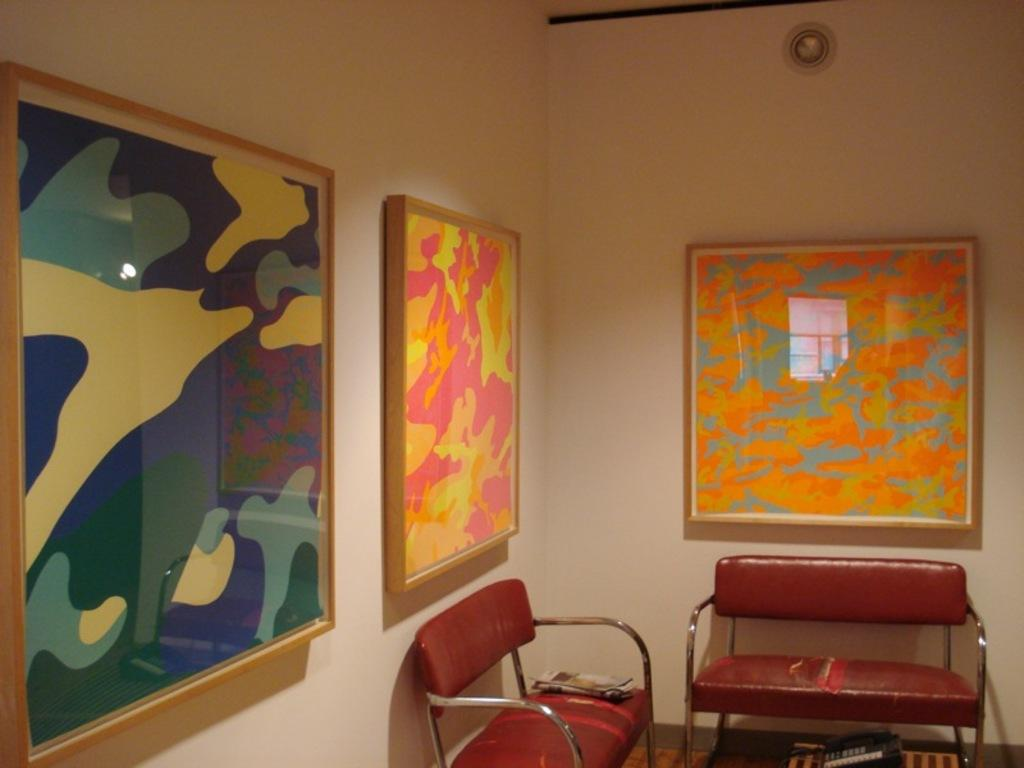How many sofas are in the room? There are two sofas in the room. What can be found on the wall in the room? There are photo frames attached to the wall. What type of bird can be seen flying over the earth in the image? There is no image of a bird or the earth in the room; the facts only mention sofas and photo frames on the wall. 